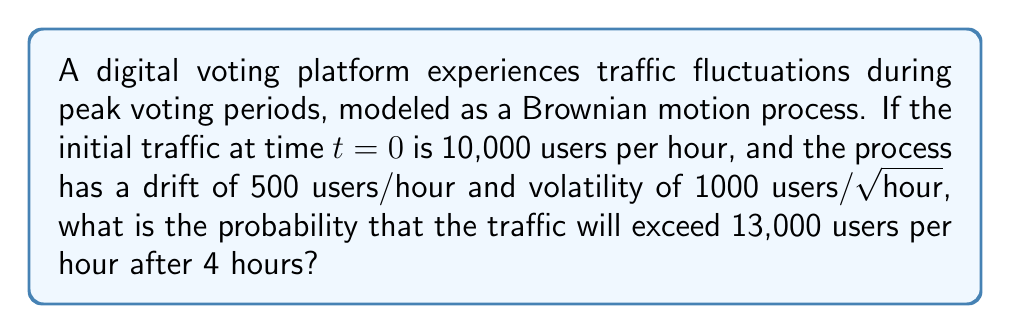Provide a solution to this math problem. To solve this problem, we'll use the properties of Brownian motion and the normal distribution:

1) In a Brownian motion model, the change in traffic $X_t$ over time $t$ follows a normal distribution:
   $X_t \sim N(\mu t, \sigma^2 t)$

   Where $\mu$ is the drift and $\sigma$ is the volatility.

2) Given:
   - Initial traffic $X_0 = 10,000$ users/hour
   - Drift $\mu = 500$ users/hour
   - Volatility $\sigma = 1000$ users/√hour
   - Time $t = 4$ hours
   - Target traffic $X_4 > 13,000$ users/hour

3) The expected traffic after 4 hours:
   $E[X_4] = X_0 + \mu t = 10,000 + 500 * 4 = 12,000$ users/hour

4) The variance of traffic after 4 hours:
   $Var[X_4] = \sigma^2 t = 1000^2 * 4 = 4,000,000$

5) To find the probability, we need to standardize the random variable:
   $Z = \frac{X_4 - E[X_4]}{\sqrt{Var[X_4]}} = \frac{X_4 - 12,000}{2000}$

6) We want $P(X_4 > 13,000)$, which is equivalent to:
   $P(Z > \frac{13,000 - 12,000}{2000}) = P(Z > 0.5)$

7) Using the standard normal distribution table or a calculator:
   $P(Z > 0.5) = 1 - P(Z \leq 0.5) = 1 - 0.6915 = 0.3085$

Therefore, the probability that the traffic will exceed 13,000 users per hour after 4 hours is approximately 0.3085 or 30.85%.
Answer: 0.3085 